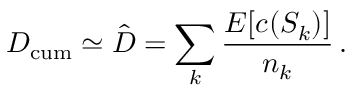<formula> <loc_0><loc_0><loc_500><loc_500>D _ { c u m } \simeq \hat { D } = \sum _ { k } \frac { E [ c ( S _ { k } ) ] } { n _ { k } } \, .</formula> 